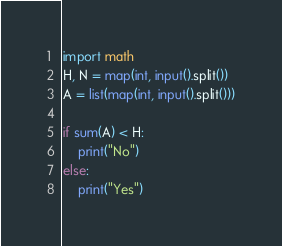<code> <loc_0><loc_0><loc_500><loc_500><_Python_>import math
H, N = map(int, input().split())
A = list(map(int, input().split()))

if sum(A) < H:
	print("No")
else:
	print("Yes")</code> 